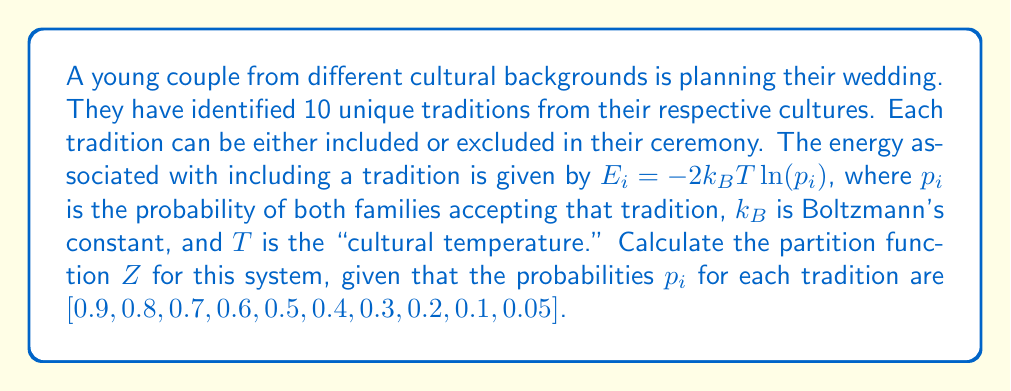What is the answer to this math problem? To solve this problem, we'll follow these steps:

1) The partition function $Z$ for a system with discrete energy levels is given by:

   $$Z = \sum_i e^{-\beta E_i}$$

   where $\beta = \frac{1}{k_BT}$

2) In this case, each tradition can be either included (with energy $E_i$) or excluded (with energy 0). So for each tradition, we have two terms in the sum:

   $$Z = \prod_{i=1}^{10} (1 + e^{-\beta E_i})$$

3) We're given that $E_i = -2k_BT\ln(p_i)$. Let's substitute this:

   $$Z = \prod_{i=1}^{10} (1 + e^{-\beta (-2k_BT\ln(p_i))})$$

4) Simplify the exponent:

   $$Z = \prod_{i=1}^{10} (1 + e^{2\ln(p_i)})$$

5) Simplify further:

   $$Z = \prod_{i=1}^{10} (1 + p_i^2)$$

6) Now, let's calculate each term:

   For $p_1 = 0.9$: $1 + 0.9^2 = 1.81$
   For $p_2 = 0.8$: $1 + 0.8^2 = 1.64$
   For $p_3 = 0.7$: $1 + 0.7^2 = 1.49$
   For $p_4 = 0.6$: $1 + 0.6^2 = 1.36$
   For $p_5 = 0.5$: $1 + 0.5^2 = 1.25$
   For $p_6 = 0.4$: $1 + 0.4^2 = 1.16$
   For $p_7 = 0.3$: $1 + 0.3^2 = 1.09$
   For $p_8 = 0.2$: $1 + 0.2^2 = 1.04$
   For $p_9 = 0.1$: $1 + 0.1^2 = 1.01$
   For $p_{10} = 0.05$: $1 + 0.05^2 = 1.0025$

7) Multiply all these terms:

   $$Z = 1.81 \times 1.64 \times 1.49 \times 1.36 \times 1.25 \times 1.16 \times 1.09 \times 1.04 \times 1.01 \times 1.0025 \approx 6.6819$$
Answer: $Z \approx 6.6819$ 